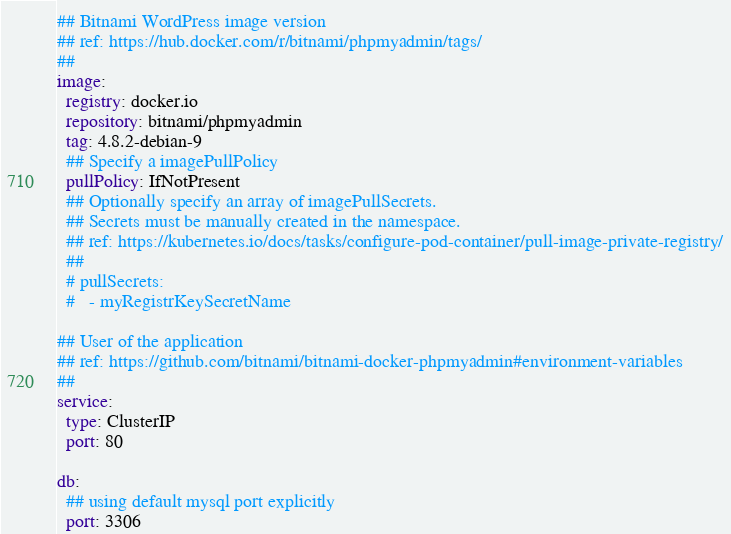<code> <loc_0><loc_0><loc_500><loc_500><_YAML_>## Bitnami WordPress image version
## ref: https://hub.docker.com/r/bitnami/phpmyadmin/tags/
##
image:
  registry: docker.io
  repository: bitnami/phpmyadmin
  tag: 4.8.2-debian-9
  ## Specify a imagePullPolicy
  pullPolicy: IfNotPresent
  ## Optionally specify an array of imagePullSecrets.
  ## Secrets must be manually created in the namespace.
  ## ref: https://kubernetes.io/docs/tasks/configure-pod-container/pull-image-private-registry/
  ##
  # pullSecrets:
  #   - myRegistrKeySecretName

## User of the application
## ref: https://github.com/bitnami/bitnami-docker-phpmyadmin#environment-variables
##
service:
  type: ClusterIP
  port: 80

db:
  ## using default mysql port explicitly
  port: 3306</code> 